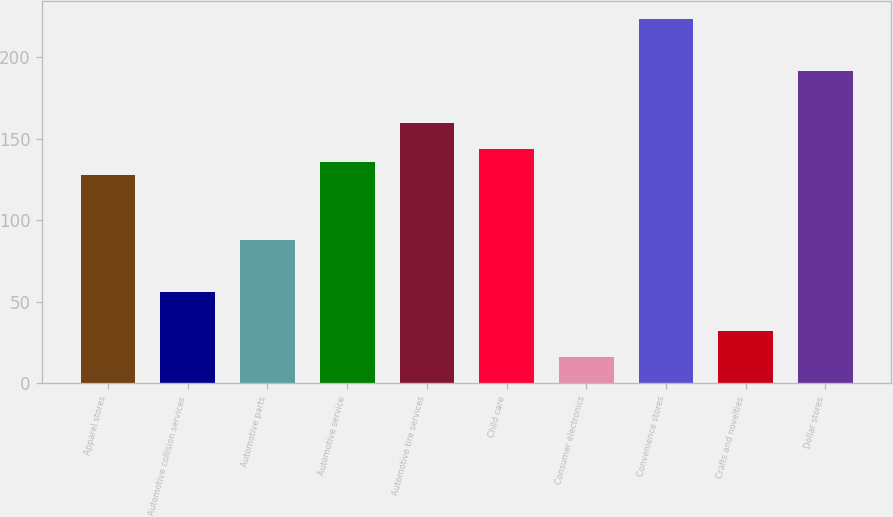Convert chart. <chart><loc_0><loc_0><loc_500><loc_500><bar_chart><fcel>Apparel stores<fcel>Automotive collision services<fcel>Automotive parts<fcel>Automotive service<fcel>Automotive tire services<fcel>Child care<fcel>Consumer electronics<fcel>Convenience stores<fcel>Crafts and novelties<fcel>Dollar stores<nl><fcel>127.62<fcel>55.89<fcel>87.77<fcel>135.59<fcel>159.5<fcel>143.56<fcel>16.04<fcel>223.26<fcel>31.98<fcel>191.38<nl></chart> 